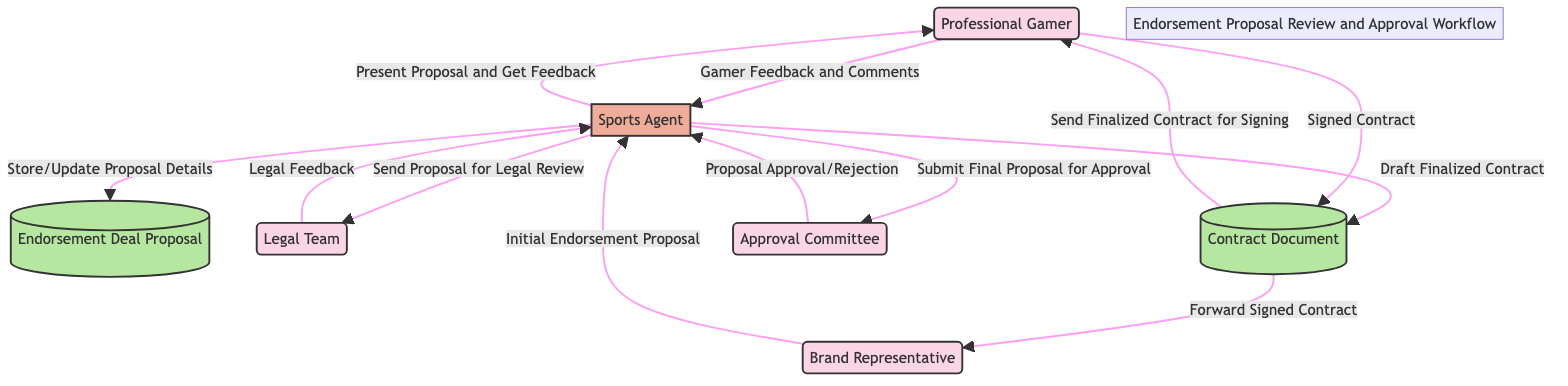What is the initial data received by the Sports Agent? The Sports Agent receives the "Initial Endorsement Proposal" from the Brand Representative.
Answer: Initial Endorsement Proposal Who does the Sports Agent present the proposal to for feedback? The Sports Agent presents the proposal to the Professional Gamer for feedback.
Answer: Professional Gamer How many external entities are present in the diagram? The diagram contains four external entities: Professional Gamer, Legal Team, Brand Representative, and Approval Committee.
Answer: Four What does the Legal Team provide back to the Sports Agent? The Legal Team provides "Legal Feedback" back to the Sports Agent after reviewing the proposal.
Answer: Legal Feedback What is the final output of the endorsement process before it reaches the Brand Representative? The final output is the "Signed Contract" from the Professional Gamer, which is then forwarded to the Brand Representative.
Answer: Signed Contract What action occurs between the Approval Committee and the Sports Agent? The Approval Committee either approves or rejects the proposal, sending the outcome back to the Sports Agent.
Answer: Proposal Approval/Rejection What document is drafted after the proposal is approved? After approval, the Sports Agent drafts the "Finalized Contract."
Answer: Finalized Contract What does the Sports Agent do with the proposal details? The Sports Agent "Stores/Updates Proposal Details" in the Endorsement Deal Proposal data store.
Answer: Store/Update Proposal Details Which entity forwards the signed contract to the Brand Representative? The "Contract Document" forwards the signed contract to the Brand Representative.
Answer: Contract Document 